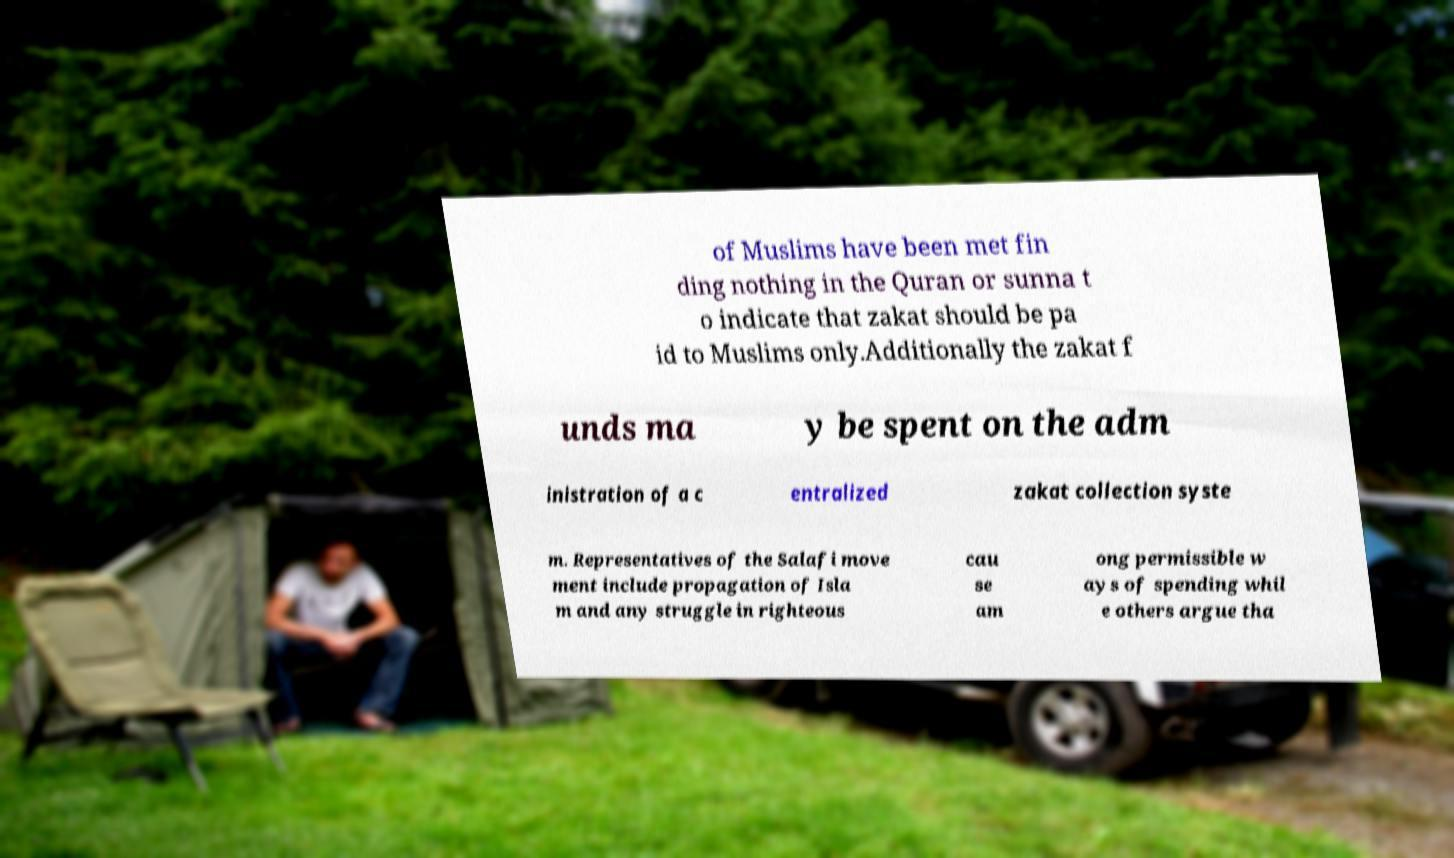Please identify and transcribe the text found in this image. of Muslims have been met fin ding nothing in the Quran or sunna t o indicate that zakat should be pa id to Muslims only.Additionally the zakat f unds ma y be spent on the adm inistration of a c entralized zakat collection syste m. Representatives of the Salafi move ment include propagation of Isla m and any struggle in righteous cau se am ong permissible w ays of spending whil e others argue tha 